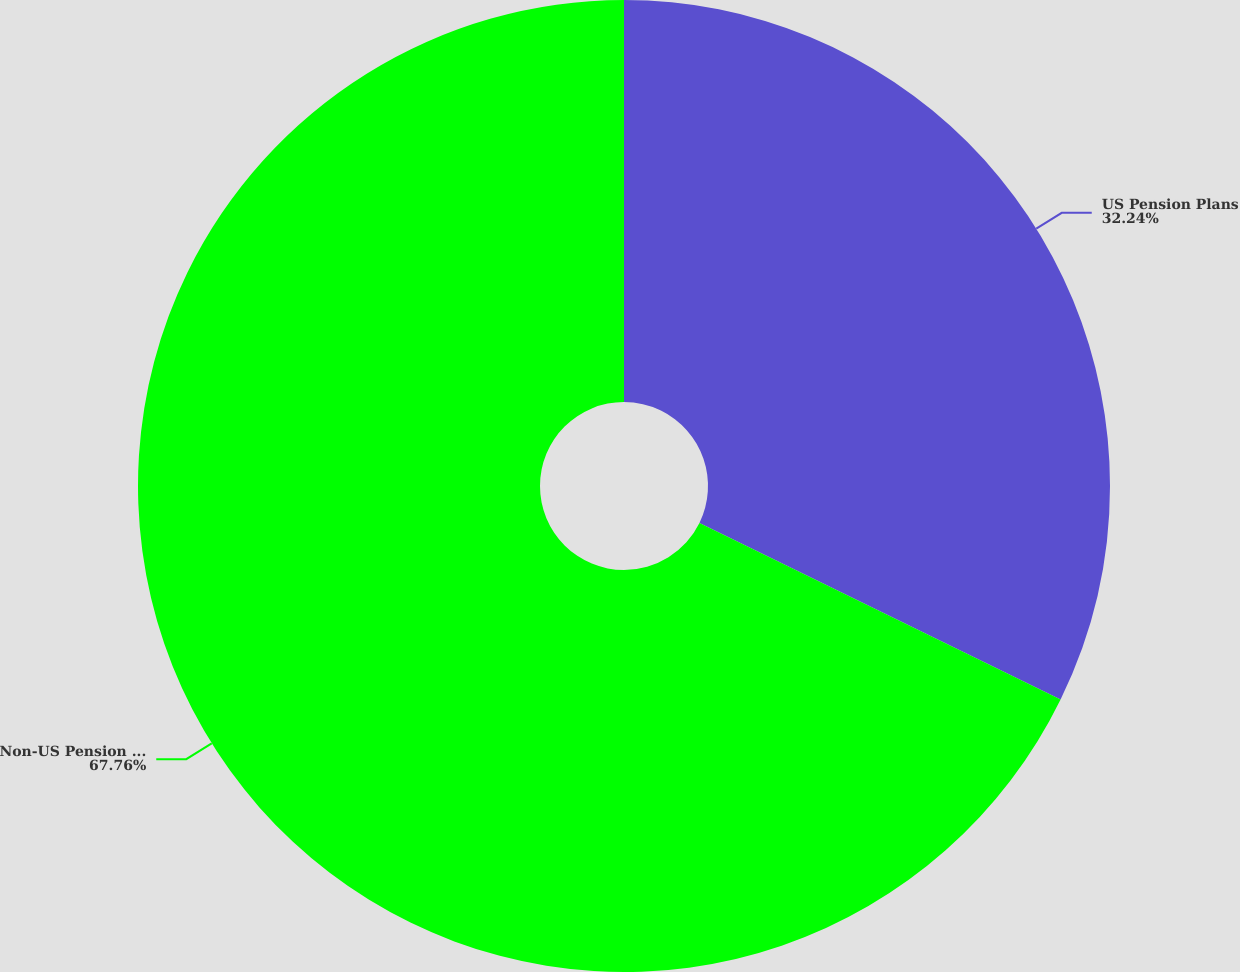Convert chart. <chart><loc_0><loc_0><loc_500><loc_500><pie_chart><fcel>US Pension Plans<fcel>Non-US Pension Plans<nl><fcel>32.24%<fcel>67.76%<nl></chart> 